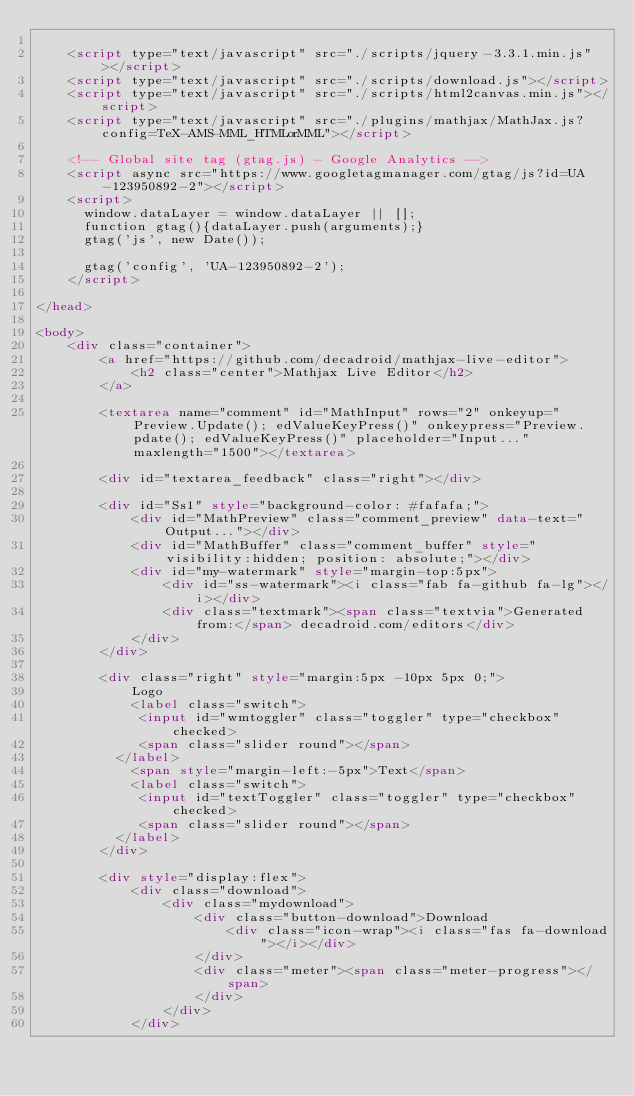Convert code to text. <code><loc_0><loc_0><loc_500><loc_500><_HTML_>
    <script type="text/javascript" src="./scripts/jquery-3.3.1.min.js"></script>
    <script type="text/javascript" src="./scripts/download.js"></script>
    <script type="text/javascript" src="./scripts/html2canvas.min.js"></script>
    <script type="text/javascript" src="./plugins/mathjax/MathJax.js?config=TeX-AMS-MML_HTMLorMML"></script>
    
    <!-- Global site tag (gtag.js) - Google Analytics -->
    <script async src="https://www.googletagmanager.com/gtag/js?id=UA-123950892-2"></script>
    <script>
      window.dataLayer = window.dataLayer || [];
      function gtag(){dataLayer.push(arguments);}
      gtag('js', new Date());

      gtag('config', 'UA-123950892-2');
    </script>
    
</head>

<body>
    <div class="container">
        <a href="https://github.com/decadroid/mathjax-live-editor">
            <h2 class="center">Mathjax Live Editor</h2>
        </a>

        <textarea name="comment" id="MathInput" rows="2" onkeyup="Preview.Update(); edValueKeyPress()" onkeypress="Preview.pdate(); edValueKeyPress()" placeholder="Input..." maxlength="1500"></textarea>

        <div id="textarea_feedback" class="right"></div>

        <div id="Ss1" style="background-color: #fafafa;">
            <div id="MathPreview" class="comment_preview" data-text="Output..."></div>
            <div id="MathBuffer" class="comment_buffer" style="visibility:hidden; position: absolute;"></div>
            <div id="my-watermark" style="margin-top:5px">
                <div id="ss-watermark"><i class="fab fa-github fa-lg"></i></div>
                <div class="textmark"><span class="textvia">Generated from:</span> decadroid.com/editors</div>
            </div>
        </div>

        <div class="right" style="margin:5px -10px 5px 0;">
            Logo
            <label class="switch">
             <input id="wmtoggler" class="toggler" type="checkbox" checked>
             <span class="slider round"></span> 
          </label>
            <span style="margin-left:-5px">Text</span>
            <label class="switch">
             <input id="textToggler" class="toggler" type="checkbox" checked>
             <span class="slider round"></span> 
          </label>
        </div>

        <div style="display:flex">
            <div class="download">
                <div class="mydownload">
                    <div class="button-download">Download
                        <div class="icon-wrap"><i class="fas fa-download"></i></div>
                    </div>
                    <div class="meter"><span class="meter-progress"></span>
                    </div>
                </div>
            </div></code> 